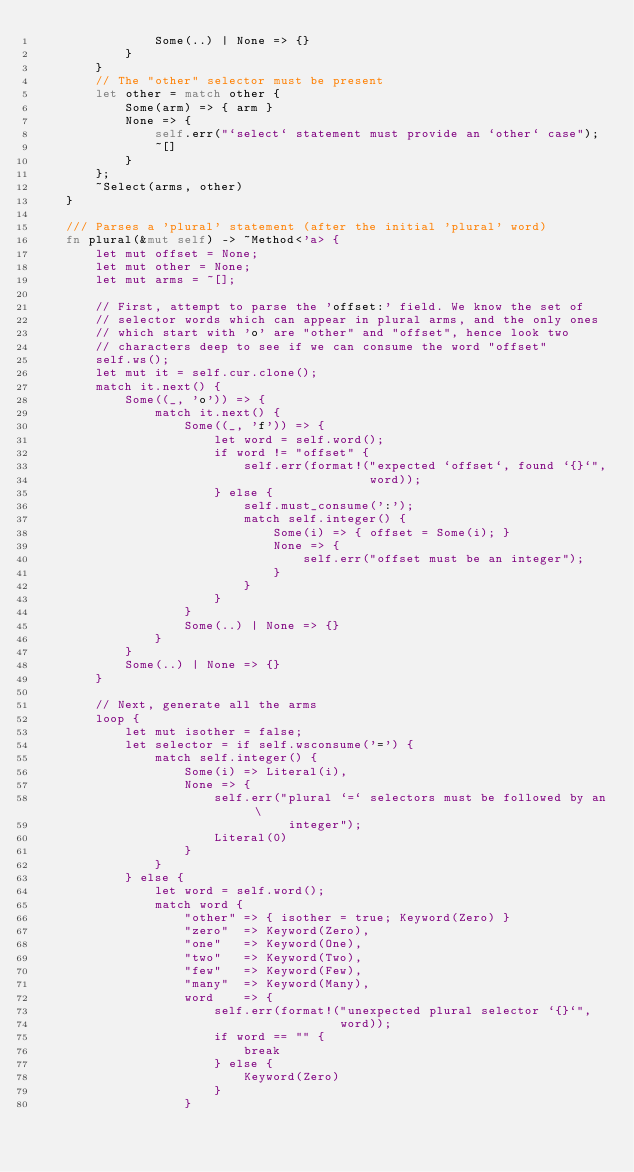<code> <loc_0><loc_0><loc_500><loc_500><_Rust_>                Some(..) | None => {}
            }
        }
        // The "other" selector must be present
        let other = match other {
            Some(arm) => { arm }
            None => {
                self.err("`select` statement must provide an `other` case");
                ~[]
            }
        };
        ~Select(arms, other)
    }

    /// Parses a 'plural' statement (after the initial 'plural' word)
    fn plural(&mut self) -> ~Method<'a> {
        let mut offset = None;
        let mut other = None;
        let mut arms = ~[];

        // First, attempt to parse the 'offset:' field. We know the set of
        // selector words which can appear in plural arms, and the only ones
        // which start with 'o' are "other" and "offset", hence look two
        // characters deep to see if we can consume the word "offset"
        self.ws();
        let mut it = self.cur.clone();
        match it.next() {
            Some((_, 'o')) => {
                match it.next() {
                    Some((_, 'f')) => {
                        let word = self.word();
                        if word != "offset" {
                            self.err(format!("expected `offset`, found `{}`",
                                             word));
                        } else {
                            self.must_consume(':');
                            match self.integer() {
                                Some(i) => { offset = Some(i); }
                                None => {
                                    self.err("offset must be an integer");
                                }
                            }
                        }
                    }
                    Some(..) | None => {}
                }
            }
            Some(..) | None => {}
        }

        // Next, generate all the arms
        loop {
            let mut isother = false;
            let selector = if self.wsconsume('=') {
                match self.integer() {
                    Some(i) => Literal(i),
                    None => {
                        self.err("plural `=` selectors must be followed by an \
                                  integer");
                        Literal(0)
                    }
                }
            } else {
                let word = self.word();
                match word {
                    "other" => { isother = true; Keyword(Zero) }
                    "zero"  => Keyword(Zero),
                    "one"   => Keyword(One),
                    "two"   => Keyword(Two),
                    "few"   => Keyword(Few),
                    "many"  => Keyword(Many),
                    word    => {
                        self.err(format!("unexpected plural selector `{}`",
                                         word));
                        if word == "" {
                            break
                        } else {
                            Keyword(Zero)
                        }
                    }</code> 